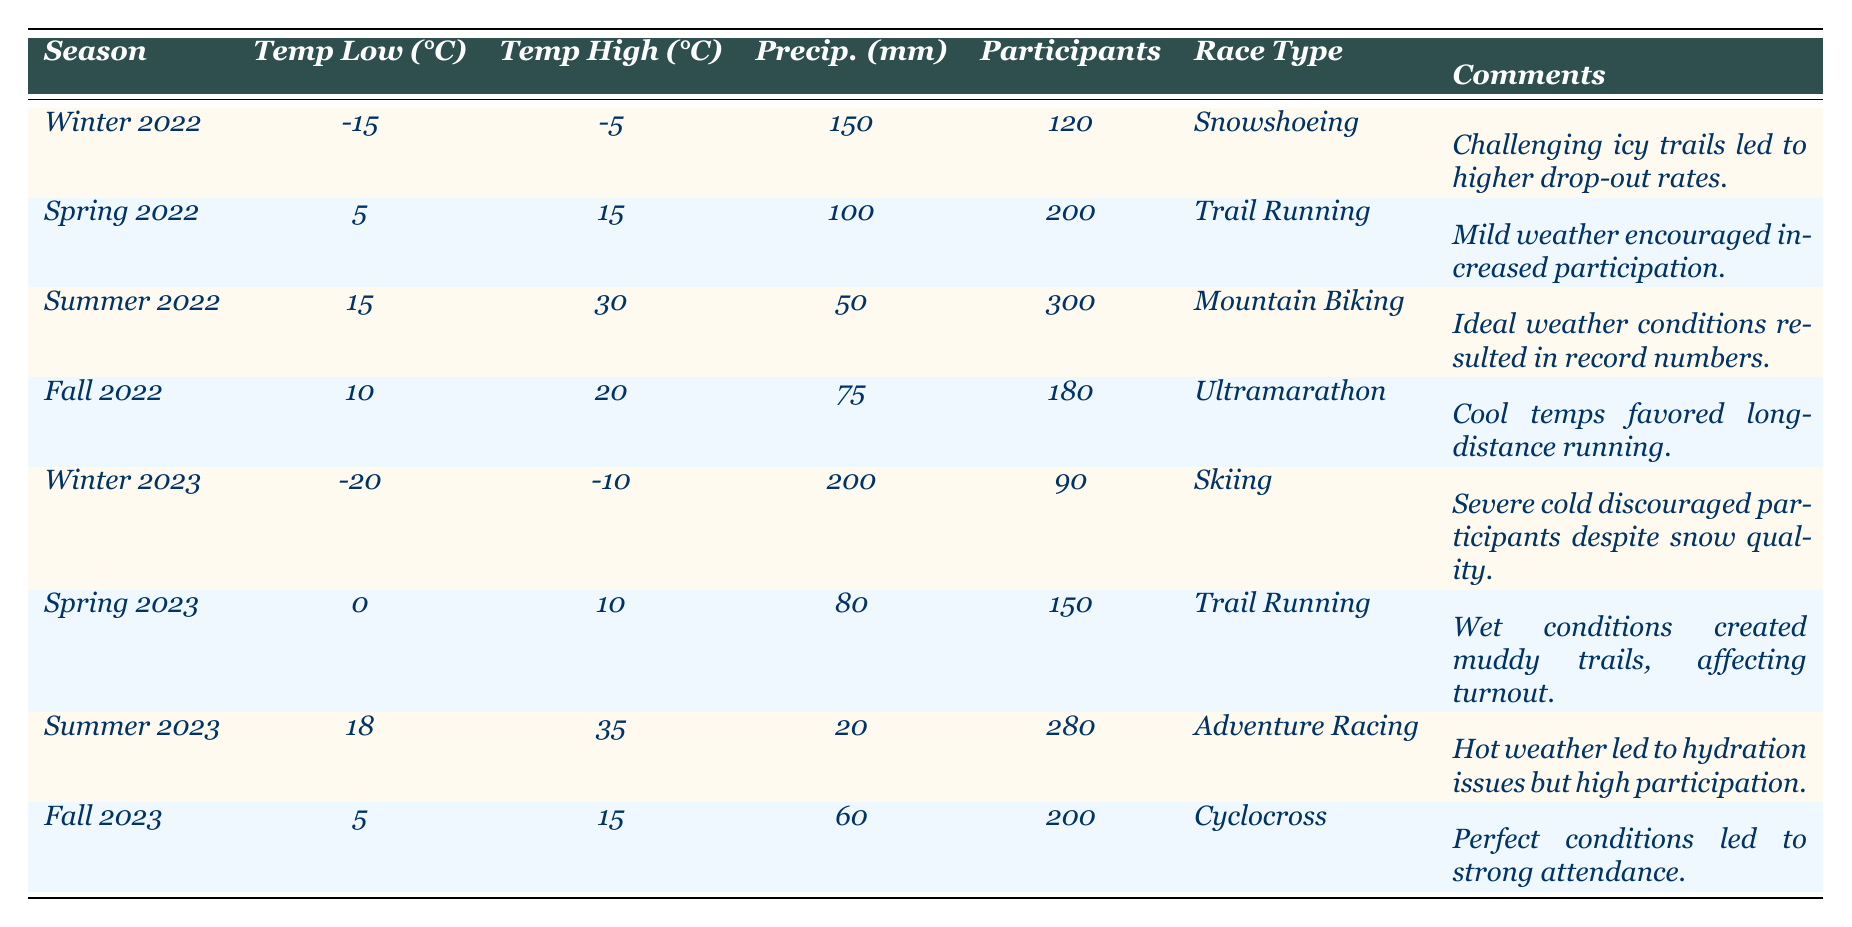What was the highest number of participants in a single race season? In the table, the highest number of participants is 300 in the "Summer 2022" season for "Mountain Biking."
Answer: 300 Which season had the lowest temperature high? The lowest temperature high is -5°C, which occurred in "Winter 2022."
Answer: Winter 2022 What is the average number of participants for the races held in spring? The number of participants in spring seasons are 200 (Spring 2022) and 150 (Spring 2023), summing them gives 200 + 150 = 350, and dividing by 2 gives an average of 175.
Answer: 175 Did "Summer 2023" have a higher participant count than "Winter 2023"? "Summer 2023" had 280 participants, while "Winter 2023" had only 90 participants, so yes, it did have a higher count.
Answer: Yes What is the total precipitation in millimeters for the races held in fall? The precipitation amounts for fall seasons are 75 mm (Fall 2022) and 60 mm (Fall 2023). Adding these gives 75 + 60 = 135 mm.
Answer: 135 mm How much lower was the participant count in "Winter 2023" compared to "Summer 2022"? "Winter 2023" had 90 participants, and "Summer 2022" had 300 participants. The difference is 300 - 90 = 210.
Answer: 210 Was the comment on "Summer 2022" related to good weather conditions? Yes, it mentions "Ideal weather conditions," indicating a positive relation to weather.
Answer: Yes Which race type had the highest participant turnout and what was it? The race type with the highest participant turnout was "Mountain Biking," with 300 participants in "Summer 2022."
Answer: Mountain Biking, 300 participants How many races had a participant count lower than 200? The race seasons with less than 200 participants are "Winter 2022" (120), "Winter 2023" (90), and "Spring 2023" (150), totaling three races.
Answer: 3 If we consider both winters, what was the average number of participants? The participant counts for the winters are 120 (Winter 2022) and 90 (Winter 2023). Adding these yields 120 + 90 = 210, and dividing by 2 gives an average of 105.
Answer: 105 